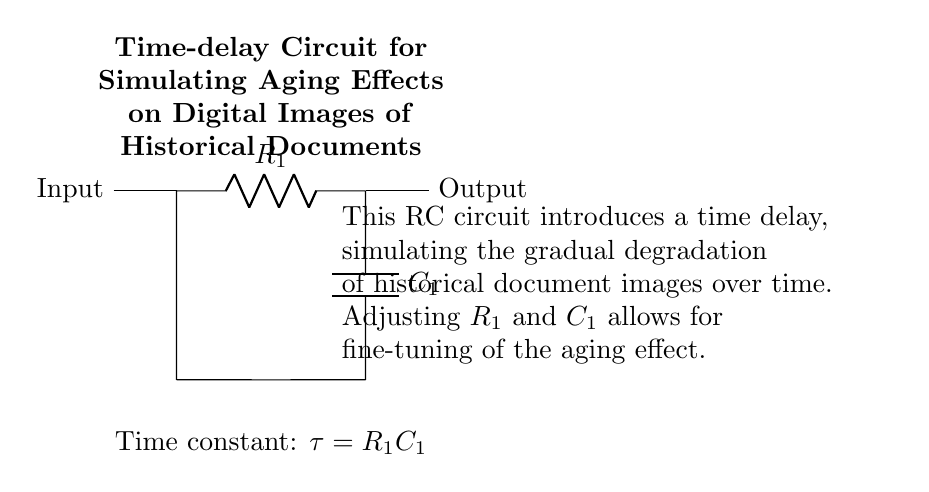What are the components in this circuit? The components in the circuit are a resistor and a capacitor. These are clearly labeled in the diagram with symbols and component values.
Answer: Resistor, Capacitor What is the arrangement of the circuit components? The resistor is placed in series with the capacitor. The diagram shows the connections starting from the input to the resistor, then to the capacitor, and back to the input point.
Answer: Series What does the term "time constant" refer to in this circuit? The time constant in an RC circuit is defined as the product of resistance and capacitance, denoted as tau equals R1 times C1. This is indicated in the diagram as a note and describes the circuit's response time.
Answer: R1C1 How does adjusting R1 affect the aging simulation? Adjusting R1 changes the resistance in the circuit, which alters the time constant. A higher resistance will increase the time delay, resulting in a slower aging effect simulation while a lower resistance reduces the delay, making the aging appear faster.
Answer: Alters time delay What is the effect of changing C1 on the circuit behavior? Changing C1 affects the capacitance, similarly influencing the time constant. A larger capacitor will increase the delay before current flows fully through the circuit, simulating a more gradual aging. Conversely, a smaller capacitor will shorten the delay, making the aging effect appear quicker.
Answer: Changes delay What is the main purpose of this RC circuit? The main purpose of this RC circuit is to simulate aging effects on digital images of historical documents by introducing a time delay. This delay mimics the gradual degradation that occurs over time.
Answer: Simulate aging effects 